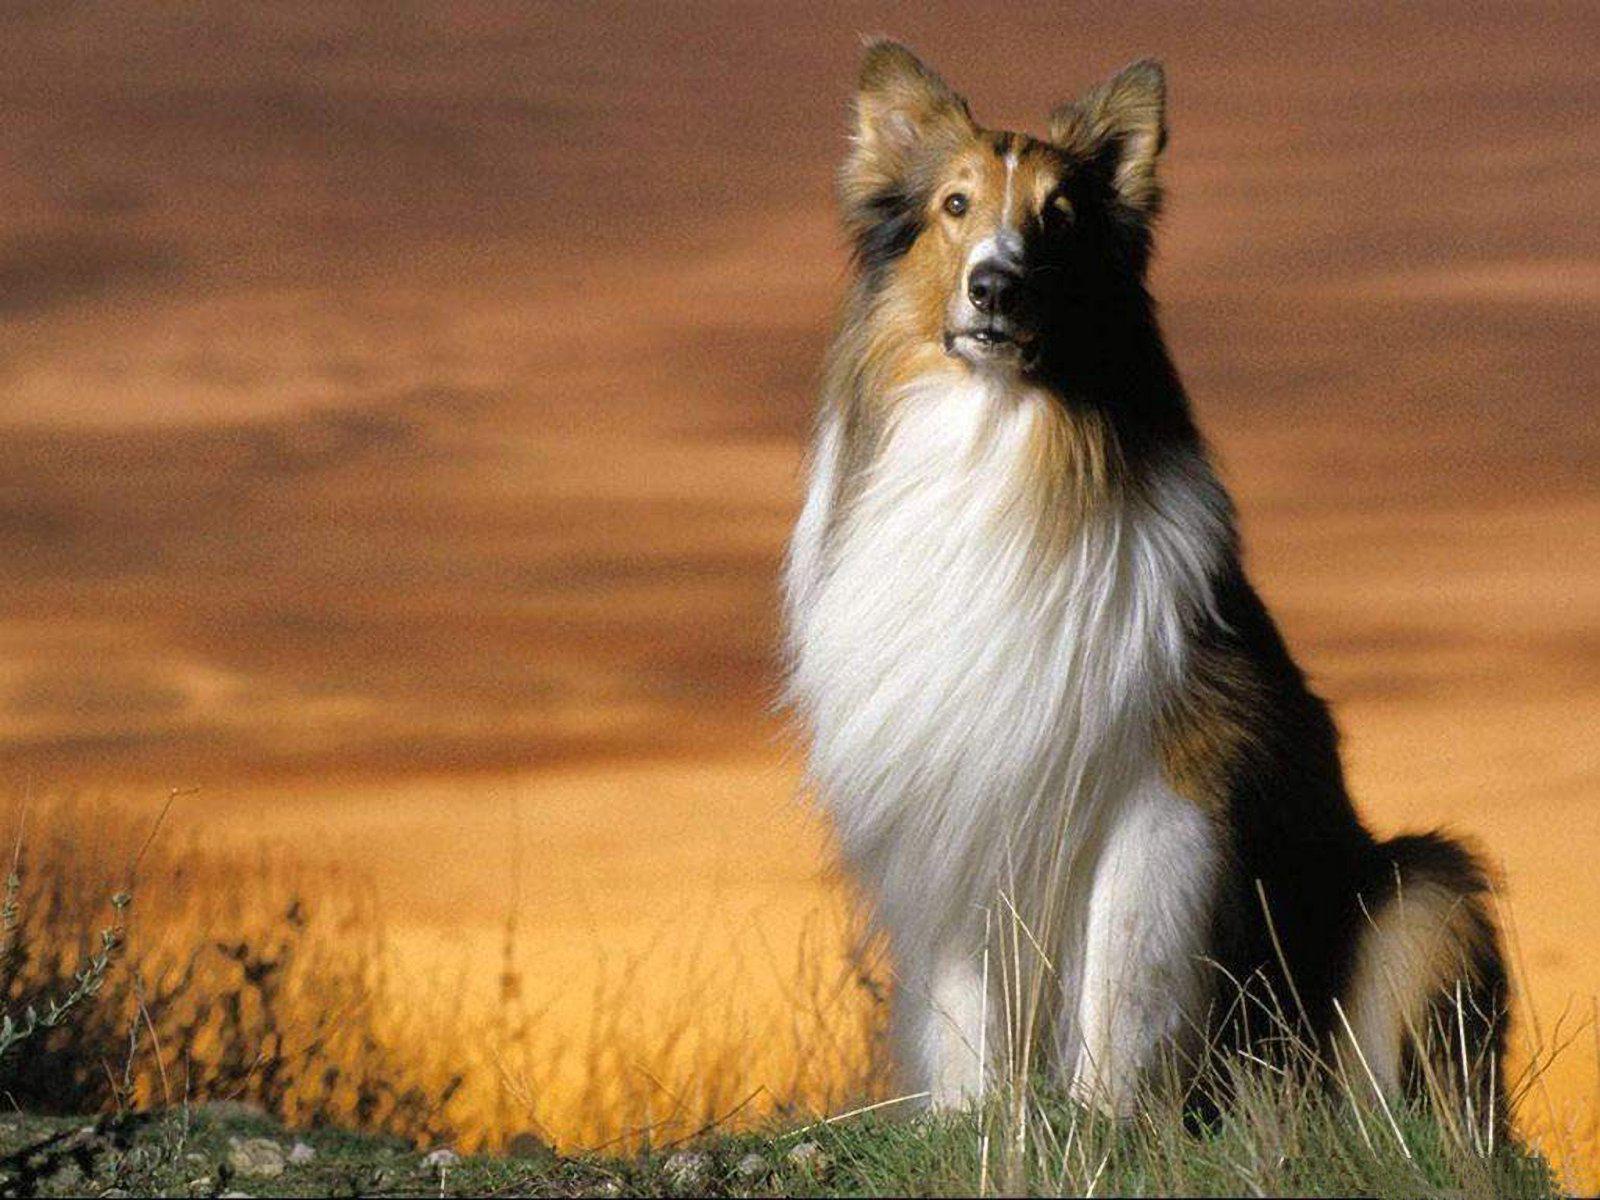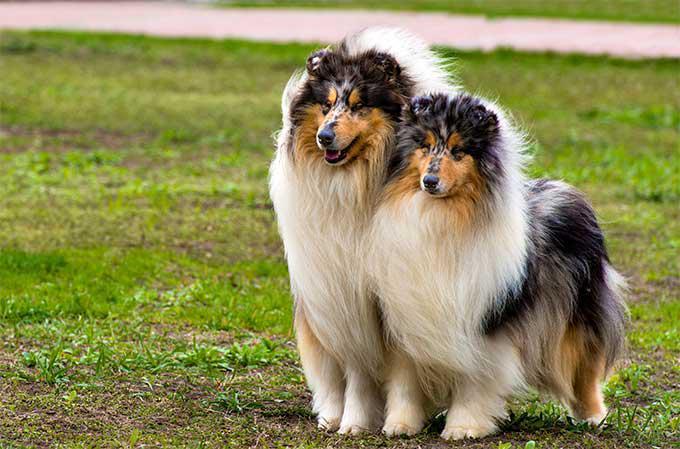The first image is the image on the left, the second image is the image on the right. Analyze the images presented: Is the assertion "The dog in the image on the right is not standing on grass." valid? Answer yes or no. No. 